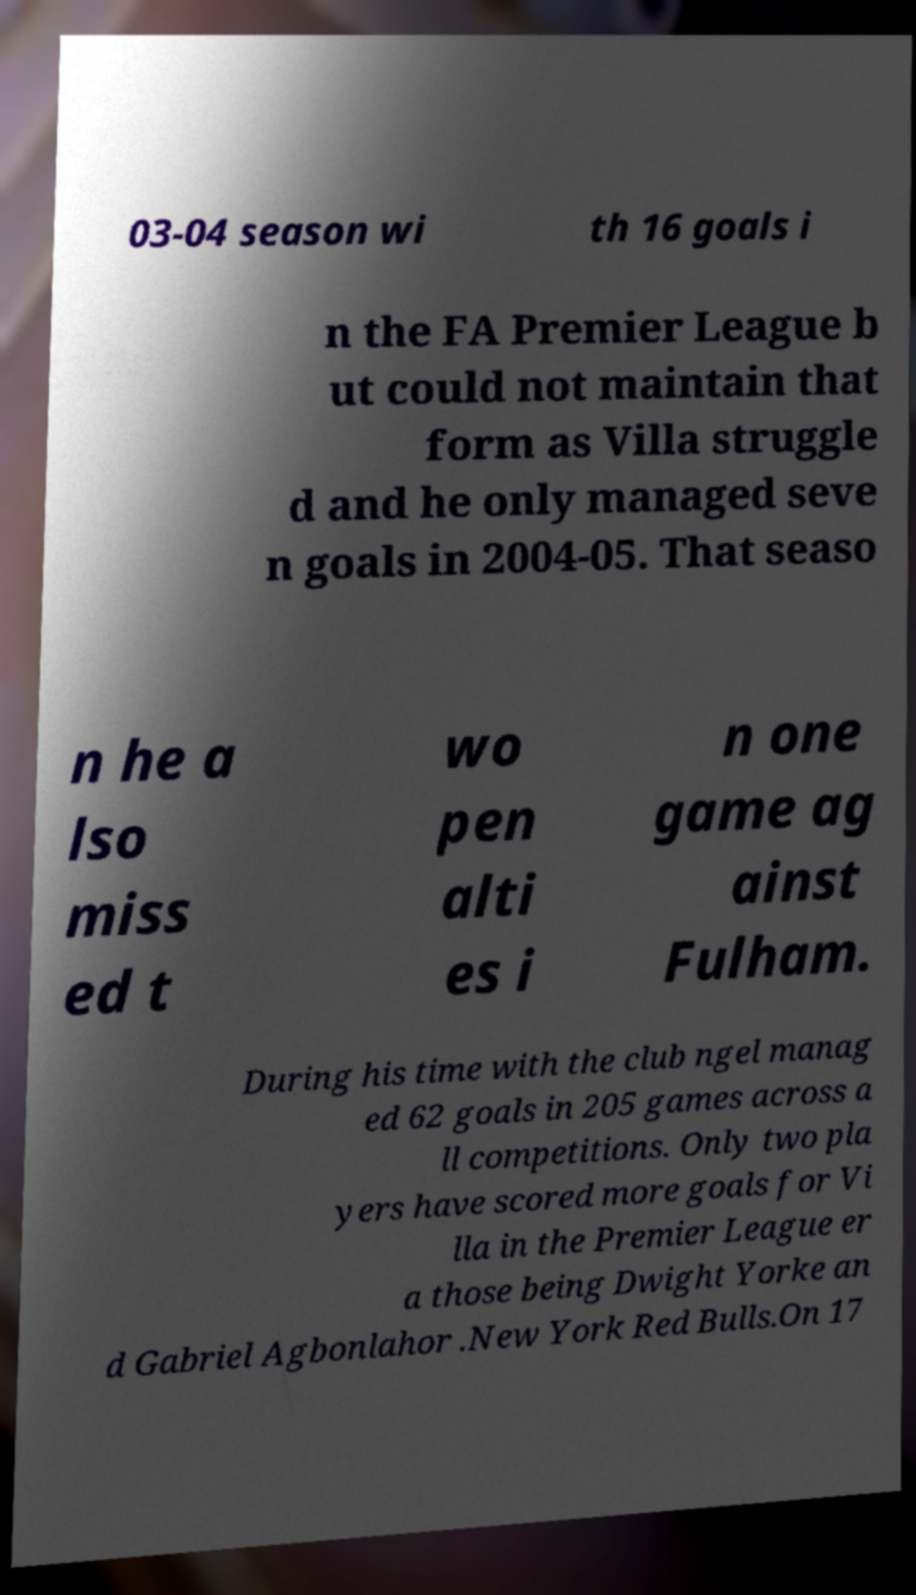Could you extract and type out the text from this image? 03-04 season wi th 16 goals i n the FA Premier League b ut could not maintain that form as Villa struggle d and he only managed seve n goals in 2004-05. That seaso n he a lso miss ed t wo pen alti es i n one game ag ainst Fulham. During his time with the club ngel manag ed 62 goals in 205 games across a ll competitions. Only two pla yers have scored more goals for Vi lla in the Premier League er a those being Dwight Yorke an d Gabriel Agbonlahor .New York Red Bulls.On 17 